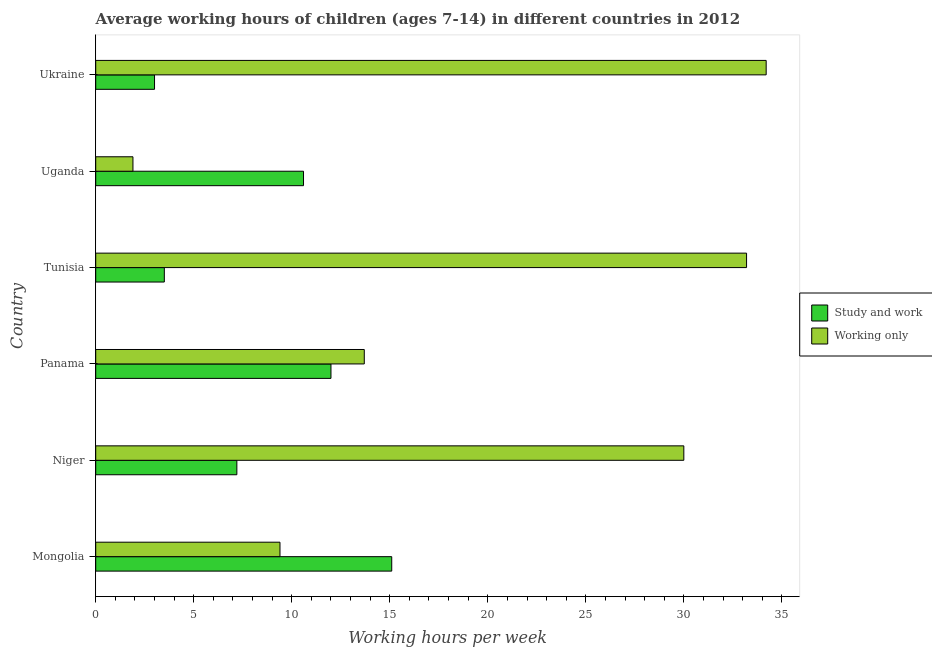How many different coloured bars are there?
Your response must be concise. 2. How many groups of bars are there?
Make the answer very short. 6. Are the number of bars per tick equal to the number of legend labels?
Your response must be concise. Yes. How many bars are there on the 2nd tick from the top?
Give a very brief answer. 2. What is the label of the 2nd group of bars from the top?
Your response must be concise. Uganda. In how many cases, is the number of bars for a given country not equal to the number of legend labels?
Offer a very short reply. 0. Across all countries, what is the minimum average working hour of children involved in only work?
Give a very brief answer. 1.9. In which country was the average working hour of children involved in only work maximum?
Offer a very short reply. Ukraine. In which country was the average working hour of children involved in only work minimum?
Make the answer very short. Uganda. What is the total average working hour of children involved in only work in the graph?
Offer a very short reply. 122.4. What is the difference between the average working hour of children involved in only work in Mongolia and that in Niger?
Offer a very short reply. -20.6. What is the average average working hour of children involved in only work per country?
Offer a very short reply. 20.4. What is the difference between the average working hour of children involved in only work and average working hour of children involved in study and work in Tunisia?
Offer a terse response. 29.7. In how many countries, is the average working hour of children involved in only work greater than 33 hours?
Offer a terse response. 2. What is the ratio of the average working hour of children involved in study and work in Uganda to that in Ukraine?
Give a very brief answer. 3.53. What is the difference between the highest and the second highest average working hour of children involved in only work?
Give a very brief answer. 1. What is the difference between the highest and the lowest average working hour of children involved in only work?
Offer a terse response. 32.3. In how many countries, is the average working hour of children involved in only work greater than the average average working hour of children involved in only work taken over all countries?
Give a very brief answer. 3. What does the 2nd bar from the top in Tunisia represents?
Your response must be concise. Study and work. What does the 1st bar from the bottom in Mongolia represents?
Give a very brief answer. Study and work. How many countries are there in the graph?
Ensure brevity in your answer.  6. Are the values on the major ticks of X-axis written in scientific E-notation?
Provide a succinct answer. No. Does the graph contain grids?
Keep it short and to the point. No. Where does the legend appear in the graph?
Your answer should be compact. Center right. How are the legend labels stacked?
Your response must be concise. Vertical. What is the title of the graph?
Your answer should be compact. Average working hours of children (ages 7-14) in different countries in 2012. Does "Largest city" appear as one of the legend labels in the graph?
Provide a succinct answer. No. What is the label or title of the X-axis?
Your answer should be very brief. Working hours per week. What is the Working hours per week in Study and work in Mongolia?
Offer a terse response. 15.1. What is the Working hours per week in Working only in Niger?
Ensure brevity in your answer.  30. What is the Working hours per week of Study and work in Panama?
Make the answer very short. 12. What is the Working hours per week of Study and work in Tunisia?
Offer a very short reply. 3.5. What is the Working hours per week in Working only in Tunisia?
Offer a terse response. 33.2. What is the Working hours per week of Working only in Uganda?
Make the answer very short. 1.9. What is the Working hours per week of Study and work in Ukraine?
Ensure brevity in your answer.  3. What is the Working hours per week in Working only in Ukraine?
Your answer should be very brief. 34.2. Across all countries, what is the maximum Working hours per week in Working only?
Provide a succinct answer. 34.2. What is the total Working hours per week in Study and work in the graph?
Give a very brief answer. 51.4. What is the total Working hours per week of Working only in the graph?
Your answer should be compact. 122.4. What is the difference between the Working hours per week of Study and work in Mongolia and that in Niger?
Provide a succinct answer. 7.9. What is the difference between the Working hours per week in Working only in Mongolia and that in Niger?
Provide a short and direct response. -20.6. What is the difference between the Working hours per week in Study and work in Mongolia and that in Panama?
Your answer should be compact. 3.1. What is the difference between the Working hours per week of Working only in Mongolia and that in Panama?
Your answer should be compact. -4.3. What is the difference between the Working hours per week in Working only in Mongolia and that in Tunisia?
Make the answer very short. -23.8. What is the difference between the Working hours per week in Study and work in Mongolia and that in Ukraine?
Ensure brevity in your answer.  12.1. What is the difference between the Working hours per week of Working only in Mongolia and that in Ukraine?
Give a very brief answer. -24.8. What is the difference between the Working hours per week in Study and work in Niger and that in Panama?
Your response must be concise. -4.8. What is the difference between the Working hours per week of Study and work in Niger and that in Tunisia?
Give a very brief answer. 3.7. What is the difference between the Working hours per week in Working only in Niger and that in Tunisia?
Offer a terse response. -3.2. What is the difference between the Working hours per week of Study and work in Niger and that in Uganda?
Keep it short and to the point. -3.4. What is the difference between the Working hours per week in Working only in Niger and that in Uganda?
Keep it short and to the point. 28.1. What is the difference between the Working hours per week in Working only in Niger and that in Ukraine?
Provide a succinct answer. -4.2. What is the difference between the Working hours per week in Study and work in Panama and that in Tunisia?
Offer a very short reply. 8.5. What is the difference between the Working hours per week of Working only in Panama and that in Tunisia?
Provide a short and direct response. -19.5. What is the difference between the Working hours per week in Working only in Panama and that in Uganda?
Offer a very short reply. 11.8. What is the difference between the Working hours per week of Working only in Panama and that in Ukraine?
Offer a very short reply. -20.5. What is the difference between the Working hours per week in Working only in Tunisia and that in Uganda?
Keep it short and to the point. 31.3. What is the difference between the Working hours per week of Working only in Tunisia and that in Ukraine?
Offer a terse response. -1. What is the difference between the Working hours per week of Working only in Uganda and that in Ukraine?
Provide a short and direct response. -32.3. What is the difference between the Working hours per week in Study and work in Mongolia and the Working hours per week in Working only in Niger?
Offer a terse response. -14.9. What is the difference between the Working hours per week of Study and work in Mongolia and the Working hours per week of Working only in Tunisia?
Give a very brief answer. -18.1. What is the difference between the Working hours per week in Study and work in Mongolia and the Working hours per week in Working only in Ukraine?
Provide a short and direct response. -19.1. What is the difference between the Working hours per week of Study and work in Niger and the Working hours per week of Working only in Tunisia?
Provide a succinct answer. -26. What is the difference between the Working hours per week of Study and work in Panama and the Working hours per week of Working only in Tunisia?
Keep it short and to the point. -21.2. What is the difference between the Working hours per week of Study and work in Panama and the Working hours per week of Working only in Ukraine?
Keep it short and to the point. -22.2. What is the difference between the Working hours per week in Study and work in Tunisia and the Working hours per week in Working only in Uganda?
Your answer should be very brief. 1.6. What is the difference between the Working hours per week in Study and work in Tunisia and the Working hours per week in Working only in Ukraine?
Your answer should be very brief. -30.7. What is the difference between the Working hours per week of Study and work in Uganda and the Working hours per week of Working only in Ukraine?
Provide a short and direct response. -23.6. What is the average Working hours per week of Study and work per country?
Offer a terse response. 8.57. What is the average Working hours per week in Working only per country?
Provide a short and direct response. 20.4. What is the difference between the Working hours per week of Study and work and Working hours per week of Working only in Mongolia?
Keep it short and to the point. 5.7. What is the difference between the Working hours per week in Study and work and Working hours per week in Working only in Niger?
Give a very brief answer. -22.8. What is the difference between the Working hours per week of Study and work and Working hours per week of Working only in Tunisia?
Ensure brevity in your answer.  -29.7. What is the difference between the Working hours per week of Study and work and Working hours per week of Working only in Ukraine?
Your response must be concise. -31.2. What is the ratio of the Working hours per week in Study and work in Mongolia to that in Niger?
Give a very brief answer. 2.1. What is the ratio of the Working hours per week of Working only in Mongolia to that in Niger?
Ensure brevity in your answer.  0.31. What is the ratio of the Working hours per week in Study and work in Mongolia to that in Panama?
Your answer should be compact. 1.26. What is the ratio of the Working hours per week of Working only in Mongolia to that in Panama?
Offer a very short reply. 0.69. What is the ratio of the Working hours per week of Study and work in Mongolia to that in Tunisia?
Provide a short and direct response. 4.31. What is the ratio of the Working hours per week of Working only in Mongolia to that in Tunisia?
Your answer should be compact. 0.28. What is the ratio of the Working hours per week of Study and work in Mongolia to that in Uganda?
Offer a very short reply. 1.42. What is the ratio of the Working hours per week in Working only in Mongolia to that in Uganda?
Offer a very short reply. 4.95. What is the ratio of the Working hours per week in Study and work in Mongolia to that in Ukraine?
Your answer should be compact. 5.03. What is the ratio of the Working hours per week of Working only in Mongolia to that in Ukraine?
Offer a terse response. 0.27. What is the ratio of the Working hours per week of Working only in Niger to that in Panama?
Make the answer very short. 2.19. What is the ratio of the Working hours per week in Study and work in Niger to that in Tunisia?
Ensure brevity in your answer.  2.06. What is the ratio of the Working hours per week of Working only in Niger to that in Tunisia?
Ensure brevity in your answer.  0.9. What is the ratio of the Working hours per week of Study and work in Niger to that in Uganda?
Keep it short and to the point. 0.68. What is the ratio of the Working hours per week of Working only in Niger to that in Uganda?
Offer a very short reply. 15.79. What is the ratio of the Working hours per week of Working only in Niger to that in Ukraine?
Offer a very short reply. 0.88. What is the ratio of the Working hours per week in Study and work in Panama to that in Tunisia?
Provide a short and direct response. 3.43. What is the ratio of the Working hours per week in Working only in Panama to that in Tunisia?
Give a very brief answer. 0.41. What is the ratio of the Working hours per week in Study and work in Panama to that in Uganda?
Your answer should be compact. 1.13. What is the ratio of the Working hours per week in Working only in Panama to that in Uganda?
Your answer should be very brief. 7.21. What is the ratio of the Working hours per week of Working only in Panama to that in Ukraine?
Give a very brief answer. 0.4. What is the ratio of the Working hours per week in Study and work in Tunisia to that in Uganda?
Provide a succinct answer. 0.33. What is the ratio of the Working hours per week in Working only in Tunisia to that in Uganda?
Your answer should be compact. 17.47. What is the ratio of the Working hours per week in Study and work in Tunisia to that in Ukraine?
Ensure brevity in your answer.  1.17. What is the ratio of the Working hours per week in Working only in Tunisia to that in Ukraine?
Your answer should be compact. 0.97. What is the ratio of the Working hours per week in Study and work in Uganda to that in Ukraine?
Your answer should be very brief. 3.53. What is the ratio of the Working hours per week of Working only in Uganda to that in Ukraine?
Give a very brief answer. 0.06. What is the difference between the highest and the second highest Working hours per week in Study and work?
Your answer should be compact. 3.1. What is the difference between the highest and the lowest Working hours per week of Working only?
Ensure brevity in your answer.  32.3. 